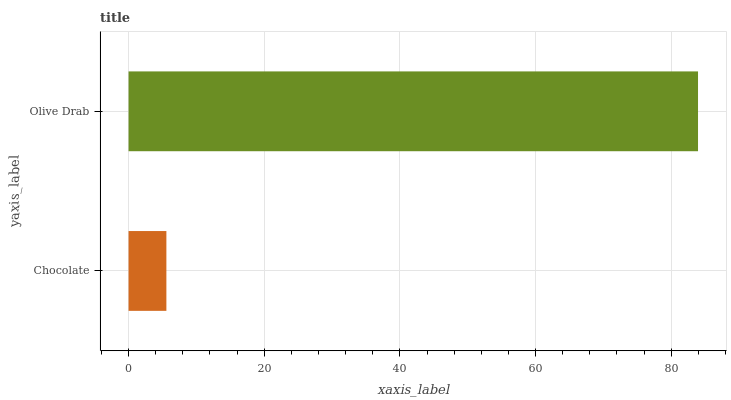Is Chocolate the minimum?
Answer yes or no. Yes. Is Olive Drab the maximum?
Answer yes or no. Yes. Is Olive Drab the minimum?
Answer yes or no. No. Is Olive Drab greater than Chocolate?
Answer yes or no. Yes. Is Chocolate less than Olive Drab?
Answer yes or no. Yes. Is Chocolate greater than Olive Drab?
Answer yes or no. No. Is Olive Drab less than Chocolate?
Answer yes or no. No. Is Olive Drab the high median?
Answer yes or no. Yes. Is Chocolate the low median?
Answer yes or no. Yes. Is Chocolate the high median?
Answer yes or no. No. Is Olive Drab the low median?
Answer yes or no. No. 